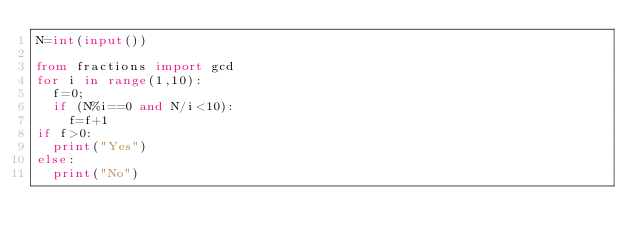Convert code to text. <code><loc_0><loc_0><loc_500><loc_500><_Python_>N=int(input())

from fractions import gcd
for i in range(1,10):
  f=0;
  if (N%i==0 and N/i<10):
    f=f+1
if f>0:
  print("Yes")
else:
  print("No")</code> 